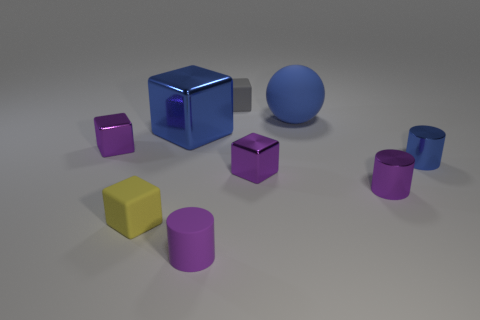Subtract 1 cubes. How many cubes are left? 4 Subtract all purple cubes. Subtract all cyan balls. How many cubes are left? 3 Add 1 tiny purple shiny blocks. How many objects exist? 10 Subtract all blocks. How many objects are left? 4 Add 4 small yellow rubber cubes. How many small yellow rubber cubes exist? 5 Subtract 0 cyan cubes. How many objects are left? 9 Subtract all large objects. Subtract all small red things. How many objects are left? 7 Add 4 gray rubber things. How many gray rubber things are left? 5 